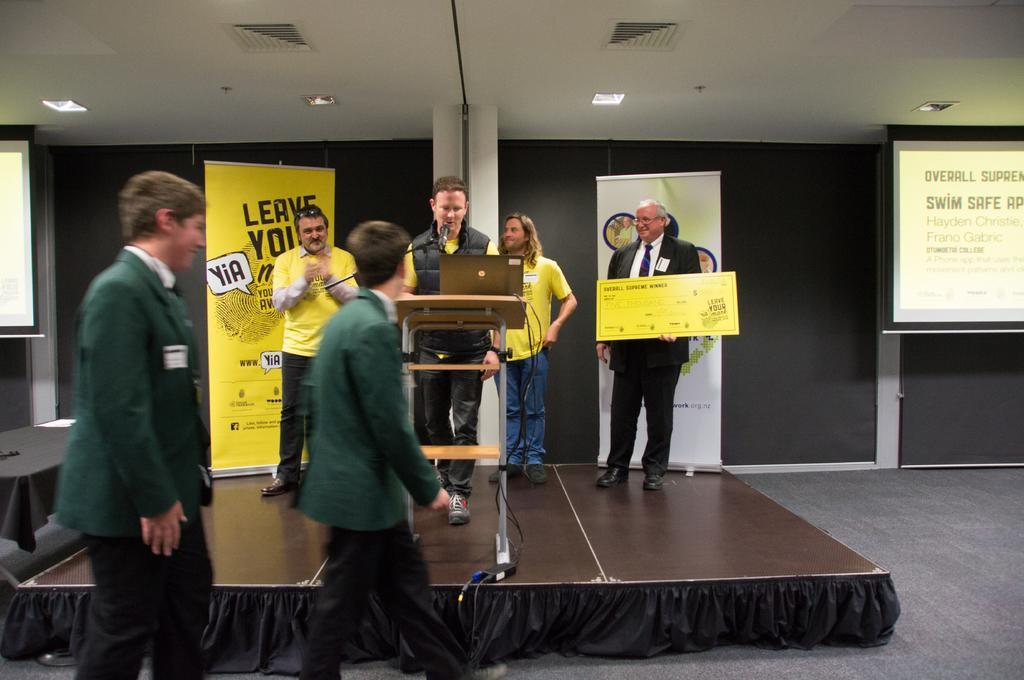Could you give a brief overview of what you see in this image? In this image I can see six persons, table, certificate, posters and a mike on the floor. In the background I can see a screen, wall and a rooftop. This image is taken may be in a hall. 